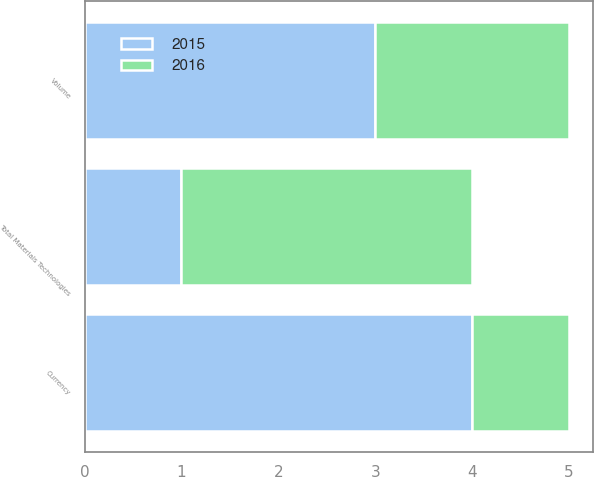<chart> <loc_0><loc_0><loc_500><loc_500><stacked_bar_chart><ecel><fcel>Volume<fcel>Currency<fcel>Total Materials Technologies<nl><fcel>2016<fcel>2<fcel>1<fcel>3<nl><fcel>2015<fcel>3<fcel>4<fcel>1<nl></chart> 